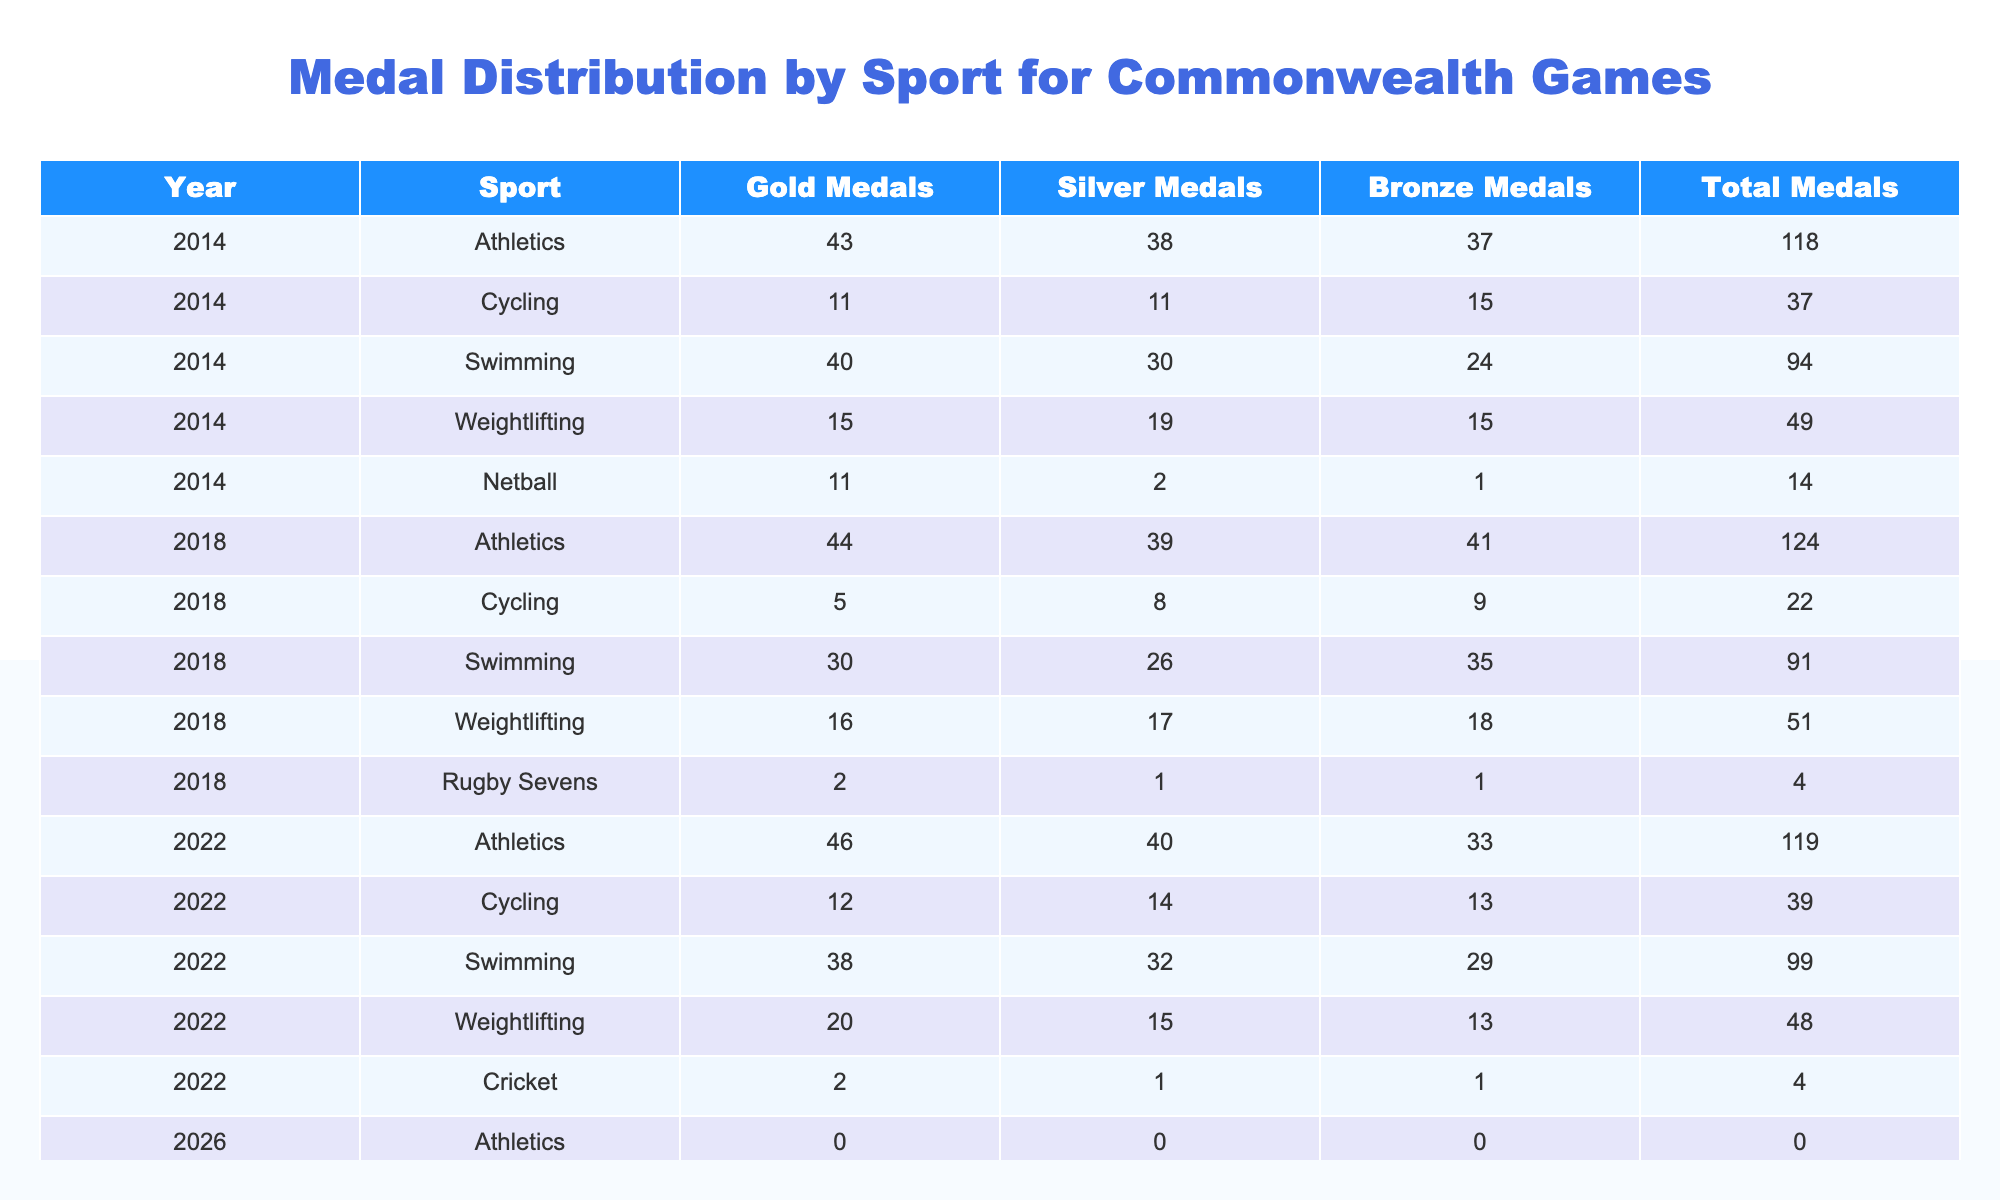What sport had the highest total medal count in 2018? Looking at the table for the year 2018, the total medals in Athletics is 124, which is higher than any other sport in that year.
Answer: Athletics How many medals did Swimming win in total across the last five games? Summing up the total medals for Swimming in each of the years listed: 94 (2014) + 91 (2018) + 99 (2022) + 0 (2026) = 284. Therefore, Swimming won a total of 284 medals.
Answer: 284 True or False: In 2022, Cricket won more medals than Rugby Sevens. According to the table, Cricket won 4 medals while Rugby Sevens did not have any medals listed for the year 2022. Since 4 is greater than 0, the statement is true.
Answer: True What is the average number of Gold medals won by Weightlifting from 2014 to 2022? For Weightlifting, over the years we have Gold medals of 15 (2014) + 16 (2018) + 20 (2022) + 0 (2026) = 51 Gold medals over 4 Games. The average is 51/4 = 12.75.
Answer: 12.75 Which sport had the lowest total medal count in 2014? In the year 2014, looking at the Total Medals column, Netball had the lowest total count with 14 medals.
Answer: Netball How many more Silver Medals did Athletics win in 2018 compared to 2014? The Silver Medals for Athletics in 2014 is 38, and in 2018 it is 39. Subtracting these, 39 - 38 = 1, meaning Athletics won 1 more Silver Medal in 2018 compared to 2014.
Answer: 1 Did Weightlifting win more Gold Medals in 2018 than in 2014? In 2014, Weightlifting won 15 Gold Medals, and in 2018, it won 16 Gold Medals. Since 16 is greater than 15, the statement is true.
Answer: True What is the total number of medals won by Athletics from 2014 to 2022? Totaling medals for Athletics from the years listed: 118 (2014) + 124 (2018) + 119 (2022) + 0 (2026) = 361. Therefore, Athletics won a total of 361 medals during this period.
Answer: 361 Which sport had more Gold Medals in 2022, Swimming or Weightlifting? Swimming won 38 Gold Medals in 2022, while Weightlifting won 20 Gold Medals. Since 38 is greater than 20, Swimming had more Gold Medals than Weightlifting in that year.
Answer: Swimming 